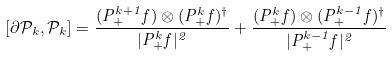Convert formula to latex. <formula><loc_0><loc_0><loc_500><loc_500>[ \partial \mathcal { P } _ { k } , \mathcal { P } _ { k } ] = \frac { ( { P } _ { + } ^ { k + 1 } f ) \otimes ( { P } _ { + } ^ { k } f ) ^ { \dagger } } { | { P } _ { + } ^ { k } f | ^ { 2 } } + \frac { ( { P } _ { + } ^ { k } f ) \otimes ( { P } _ { + } ^ { k - 1 } f ) ^ { \dagger } } { | { P } _ { + } ^ { k - 1 } f | ^ { 2 } }</formula> 